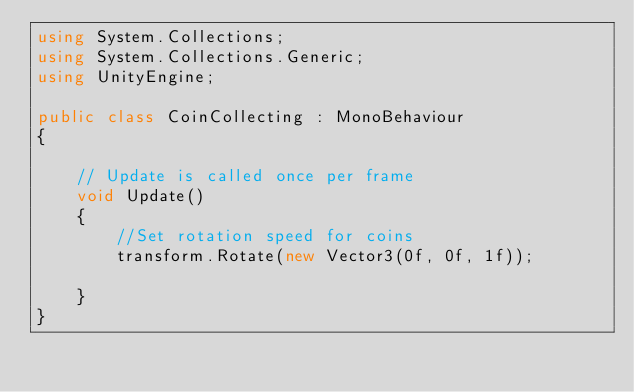<code> <loc_0><loc_0><loc_500><loc_500><_C#_>using System.Collections;
using System.Collections.Generic;
using UnityEngine;

public class CoinCollecting : MonoBehaviour
{
    
    // Update is called once per frame
    void Update()
    {
        //Set rotation speed for coins
        transform.Rotate(new Vector3(0f, 0f, 1f));
        
    }
}
</code> 